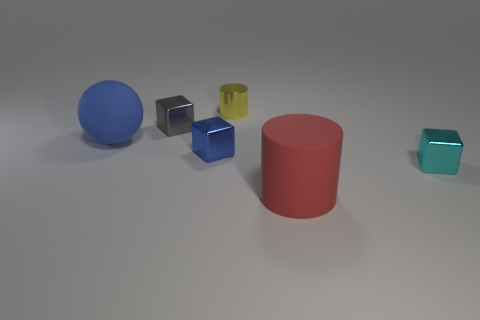There is a shiny object that is right of the matte cylinder; how big is it?
Provide a short and direct response. Small. Are there any other things that are the same size as the yellow metal cylinder?
Provide a short and direct response. Yes. There is a small thing that is to the left of the cyan thing and in front of the small gray object; what is its color?
Offer a very short reply. Blue. Do the tiny blue thing that is on the right side of the matte sphere and the yellow cylinder have the same material?
Give a very brief answer. Yes. Is the color of the small cylinder the same as the cylinder in front of the tiny gray block?
Provide a short and direct response. No. There is a tiny cyan thing; are there any shiny objects to the right of it?
Give a very brief answer. No. Do the matte thing that is to the left of the tiny blue metal object and the blue object in front of the blue sphere have the same size?
Your response must be concise. No. Are there any other blue balls that have the same size as the blue ball?
Ensure brevity in your answer.  No. Does the large thing in front of the blue matte ball have the same shape as the tiny cyan thing?
Make the answer very short. No. There is a thing that is to the right of the rubber cylinder; what material is it?
Give a very brief answer. Metal. 